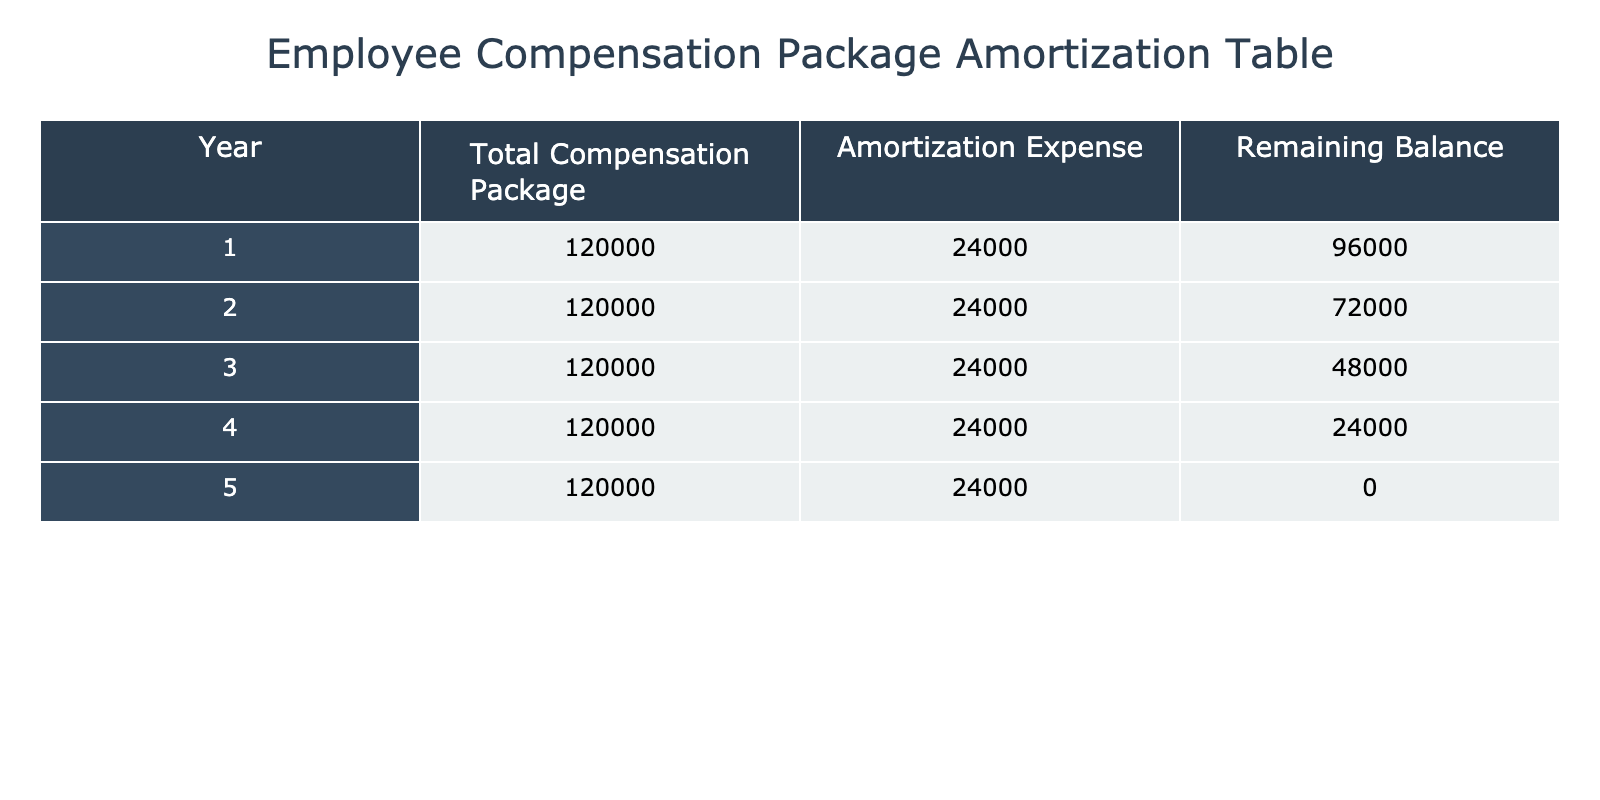What is the total compensation package for each year? According to the table, the total compensation package remains constant at 120000 for each of the five years.
Answer: 120000 What is the amortization expense for year 3? The table lists the amortization expense for each year, which is consistently 24000 throughout the 5 years.
Answer: 24000 Is the remaining balance for year 4 greater than the remaining balance for year 2? Referring to the table, the remaining balance for year 4 is 24000, while for year 2 it is 72000. Since 24000 is not greater than 72000, the statement is false.
Answer: No What is the total amortization expense over the 5 years? The amortization expense per year is 24000, and there are 5 years. Thus, the total amortization expense is calculated as 24000 multiplied by 5, which equals 120000.
Answer: 120000 Is the amortization expense the same for every year? By looking at the amortization expenses listed in the table, it is evident that each year has an expense of 24000, confirming that the expenses are consistent across the years.
Answer: Yes What is the remaining balance at the end of year 1 compared to year 3? The remaining balance at the end of year 1 is 96000, while at the end of year 3 it is 48000. Since 96000 is greater than 48000, this indicates a decreasing balance over the years.
Answer: Yes What is the average remaining balance over the 5 years? The remaining balances for the 5 years are 96000, 72000, 48000, 24000, and 0. We calculate the total sum of these balances (96000 + 72000 + 48000 + 24000 + 0 = 240000) and divide by 5, resulting in an average remaining balance of 48000.
Answer: 48000 How much does the remaining balance decrease each year? The remaining balance decreases consistently: from 96000 to 72000 for year 1 to year 2 (24000 decrease), from 72000 to 48000 for year 2 to year 3 (24000 decrease), and so on. Therefore, the decrease each year is uniform at 24000.
Answer: 24000 What is the relationship between the total compensation package and the amortization expense? The total compensation package is 120000 for each year, and the amortization expense is 24000, indicating that the amortization expense is 20% of the total compensation package. This shows a proportional relationship between the two values.
Answer: 20% 